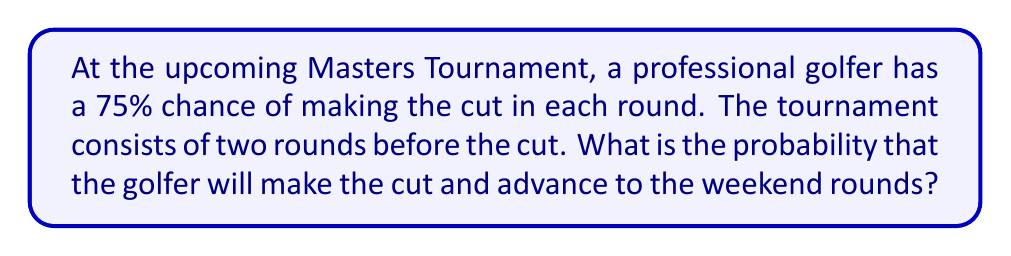Can you solve this math problem? Let's approach this step-by-step:

1) To make the cut, the golfer needs to perform well enough in both rounds.

2) The probability of making the cut in each round is 75% or 0.75.

3) Since the golfer needs to make the cut in both rounds, we need to calculate the probability of two independent events both occurring.

4) In probability theory, when we want the probability of two independent events both occurring, we multiply their individual probabilities.

5) Therefore, the probability of making the cut for both rounds is:

   $$P(\text{making cut}) = P(\text{round 1}) \times P(\text{round 2})$$
   $$P(\text{making cut}) = 0.75 \times 0.75$$
   $$P(\text{making cut}) = 0.5625$$

6) Converting to a percentage:
   $$0.5625 \times 100\% = 56.25\%$$

Thus, the probability that the golfer will make the cut and advance to the weekend rounds is 56.25%.
Answer: 56.25% 